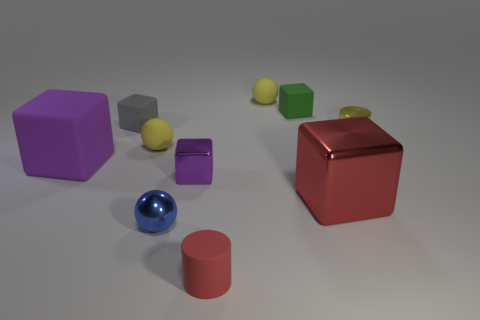Are there any other things that are the same shape as the red rubber object?
Ensure brevity in your answer.  Yes. Do the small yellow ball to the left of the tiny rubber cylinder and the big cube that is in front of the big purple rubber block have the same material?
Your answer should be compact. No. What is the material of the tiny green block?
Provide a short and direct response. Rubber. How many green cubes have the same material as the small yellow cylinder?
Offer a very short reply. 0. What number of matte things are either tiny yellow cylinders or yellow spheres?
Provide a succinct answer. 2. There is a small yellow thing that is behind the tiny yellow cylinder; is it the same shape as the big object to the left of the purple metallic cube?
Make the answer very short. No. There is a object that is both in front of the purple metallic object and on the left side of the tiny red rubber thing; what is its color?
Your answer should be compact. Blue. There is a red thing in front of the red metal object; is it the same size as the cylinder that is on the right side of the red rubber object?
Ensure brevity in your answer.  Yes. What number of matte cylinders are the same color as the metallic cylinder?
Make the answer very short. 0. How many large things are either red metal blocks or matte blocks?
Offer a very short reply. 2. 